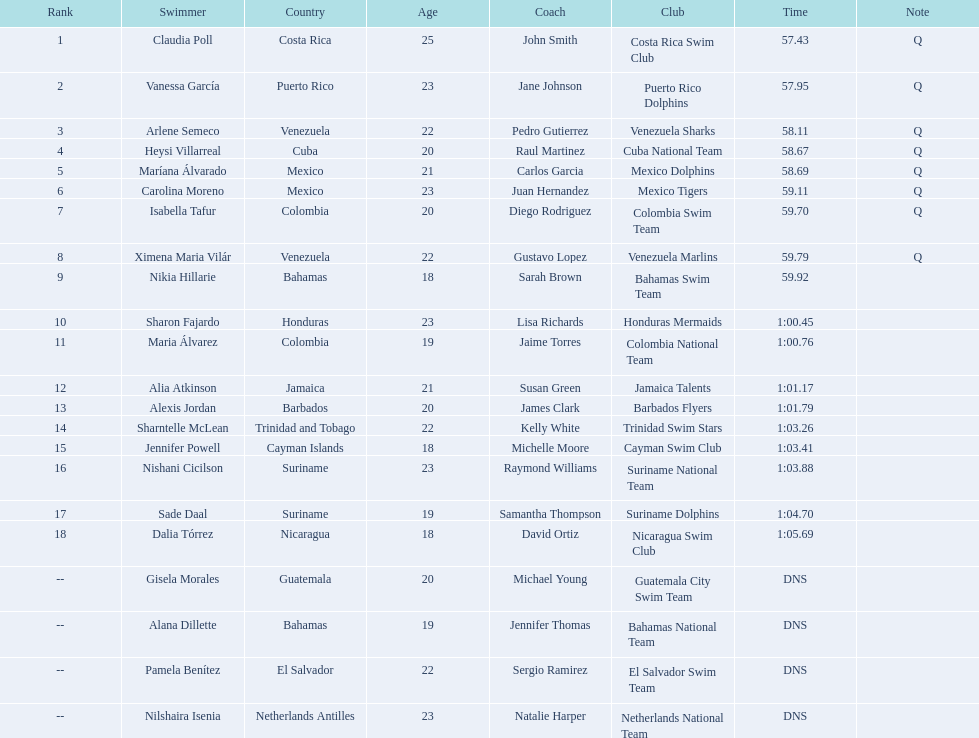How many swimmers had a time of at least 1:00 9. 